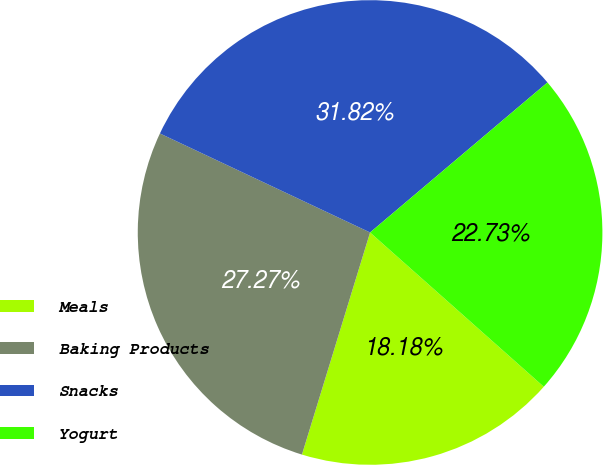Convert chart. <chart><loc_0><loc_0><loc_500><loc_500><pie_chart><fcel>Meals<fcel>Baking Products<fcel>Snacks<fcel>Yogurt<nl><fcel>18.18%<fcel>27.27%<fcel>31.82%<fcel>22.73%<nl></chart> 